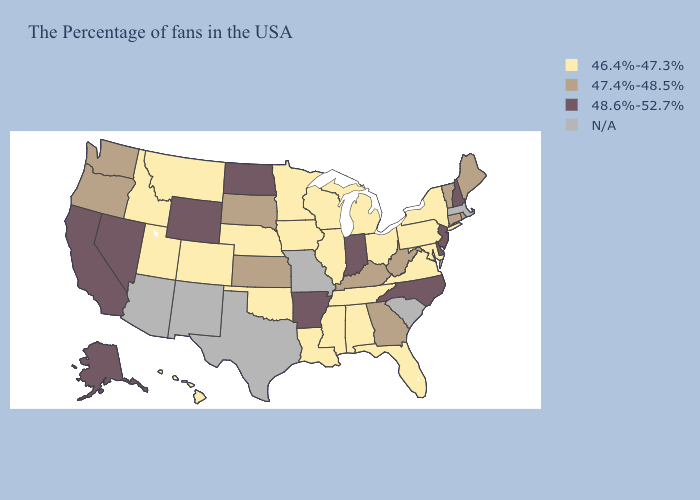What is the lowest value in states that border Texas?
Keep it brief. 46.4%-47.3%. What is the value of Wisconsin?
Answer briefly. 46.4%-47.3%. Does North Dakota have the highest value in the USA?
Write a very short answer. Yes. Name the states that have a value in the range 46.4%-47.3%?
Write a very short answer. New York, Maryland, Pennsylvania, Virginia, Ohio, Florida, Michigan, Alabama, Tennessee, Wisconsin, Illinois, Mississippi, Louisiana, Minnesota, Iowa, Nebraska, Oklahoma, Colorado, Utah, Montana, Idaho, Hawaii. Name the states that have a value in the range 46.4%-47.3%?
Give a very brief answer. New York, Maryland, Pennsylvania, Virginia, Ohio, Florida, Michigan, Alabama, Tennessee, Wisconsin, Illinois, Mississippi, Louisiana, Minnesota, Iowa, Nebraska, Oklahoma, Colorado, Utah, Montana, Idaho, Hawaii. Among the states that border Arizona , which have the highest value?
Quick response, please. Nevada, California. Which states have the lowest value in the Northeast?
Give a very brief answer. New York, Pennsylvania. Name the states that have a value in the range 46.4%-47.3%?
Short answer required. New York, Maryland, Pennsylvania, Virginia, Ohio, Florida, Michigan, Alabama, Tennessee, Wisconsin, Illinois, Mississippi, Louisiana, Minnesota, Iowa, Nebraska, Oklahoma, Colorado, Utah, Montana, Idaho, Hawaii. What is the value of New Hampshire?
Short answer required. 48.6%-52.7%. Does the first symbol in the legend represent the smallest category?
Quick response, please. Yes. What is the value of Florida?
Keep it brief. 46.4%-47.3%. What is the value of California?
Keep it brief. 48.6%-52.7%. Does Wisconsin have the highest value in the USA?
Answer briefly. No. 